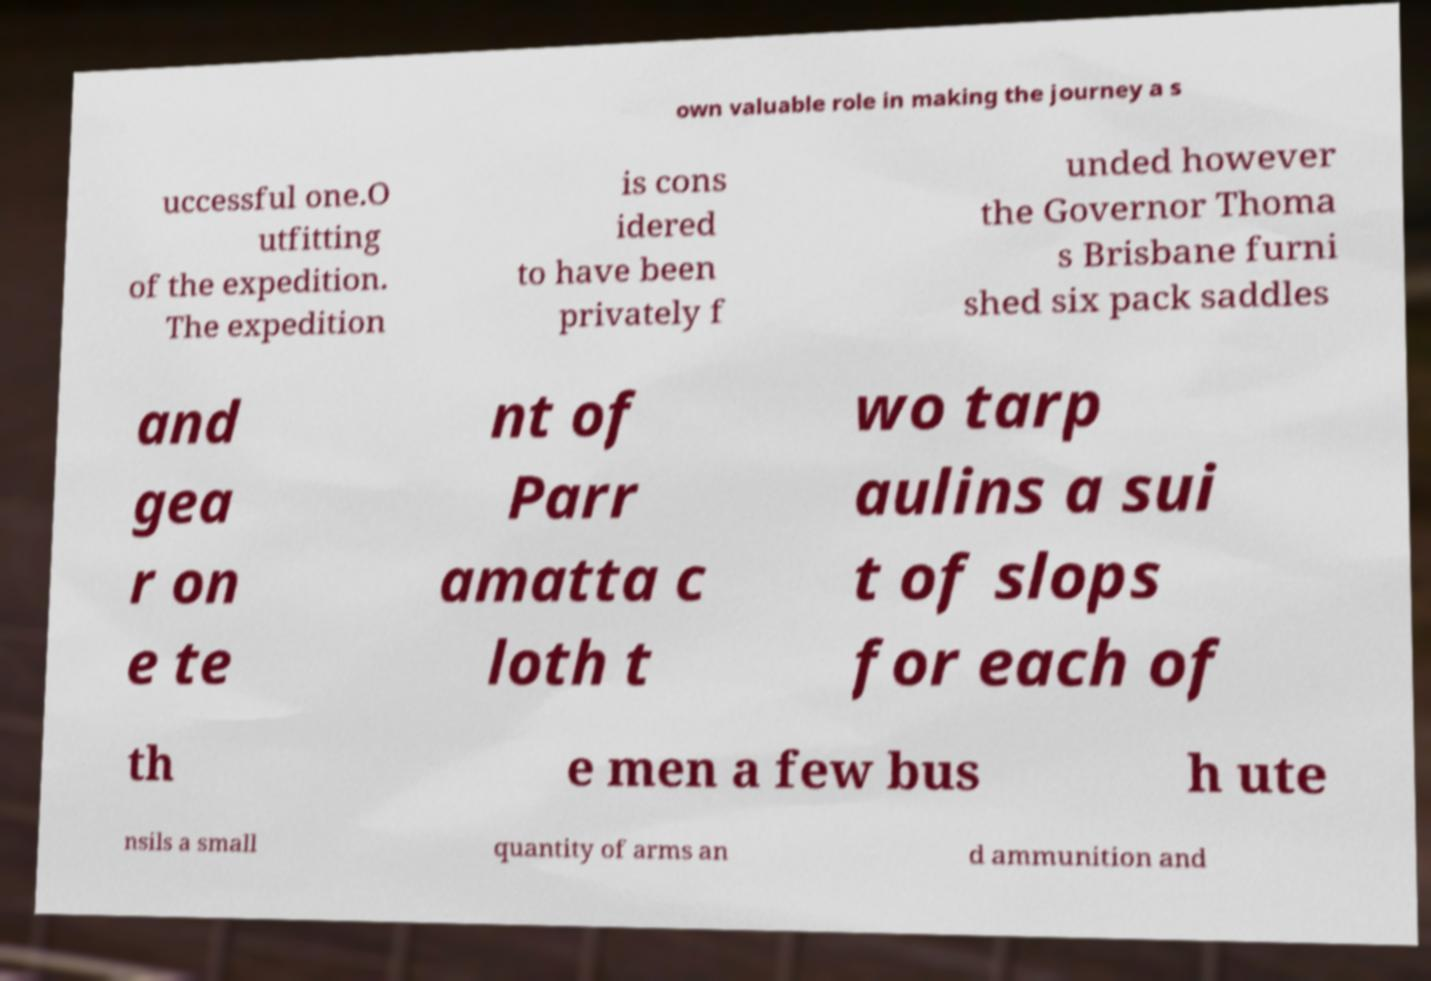Please identify and transcribe the text found in this image. own valuable role in making the journey a s uccessful one.O utfitting of the expedition. The expedition is cons idered to have been privately f unded however the Governor Thoma s Brisbane furni shed six pack saddles and gea r on e te nt of Parr amatta c loth t wo tarp aulins a sui t of slops for each of th e men a few bus h ute nsils a small quantity of arms an d ammunition and 